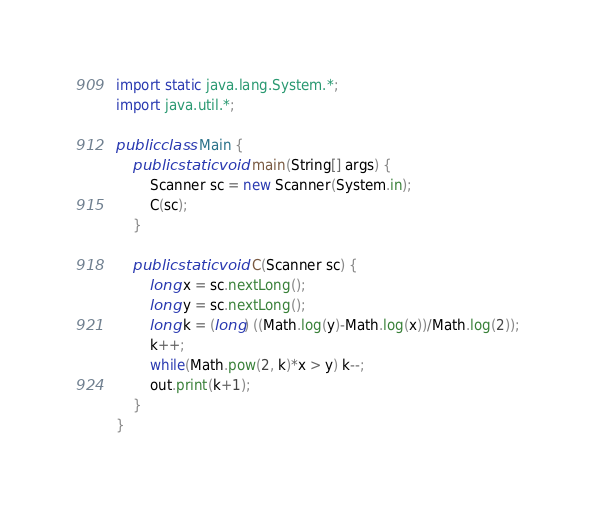<code> <loc_0><loc_0><loc_500><loc_500><_Java_>import static java.lang.System.*;
import java.util.*;

public class Main {
	public static void main(String[] args) {
		Scanner sc = new Scanner(System.in);
		C(sc);
	}
	
	public static void C(Scanner sc) {
		long x = sc.nextLong();
		long y = sc.nextLong();
		long k = (long) ((Math.log(y)-Math.log(x))/Math.log(2));
		k++;
		while(Math.pow(2, k)*x > y) k--;
		out.print(k+1);
	}
}</code> 